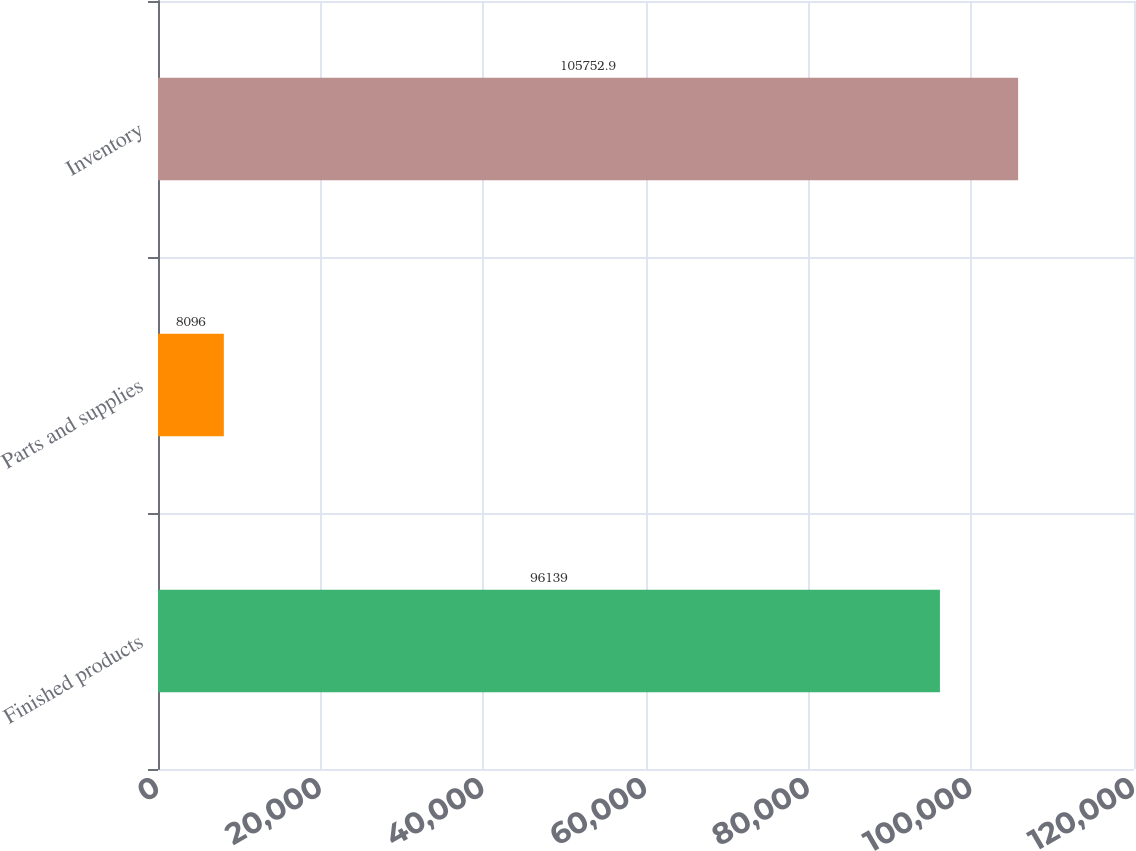<chart> <loc_0><loc_0><loc_500><loc_500><bar_chart><fcel>Finished products<fcel>Parts and supplies<fcel>Inventory<nl><fcel>96139<fcel>8096<fcel>105753<nl></chart> 